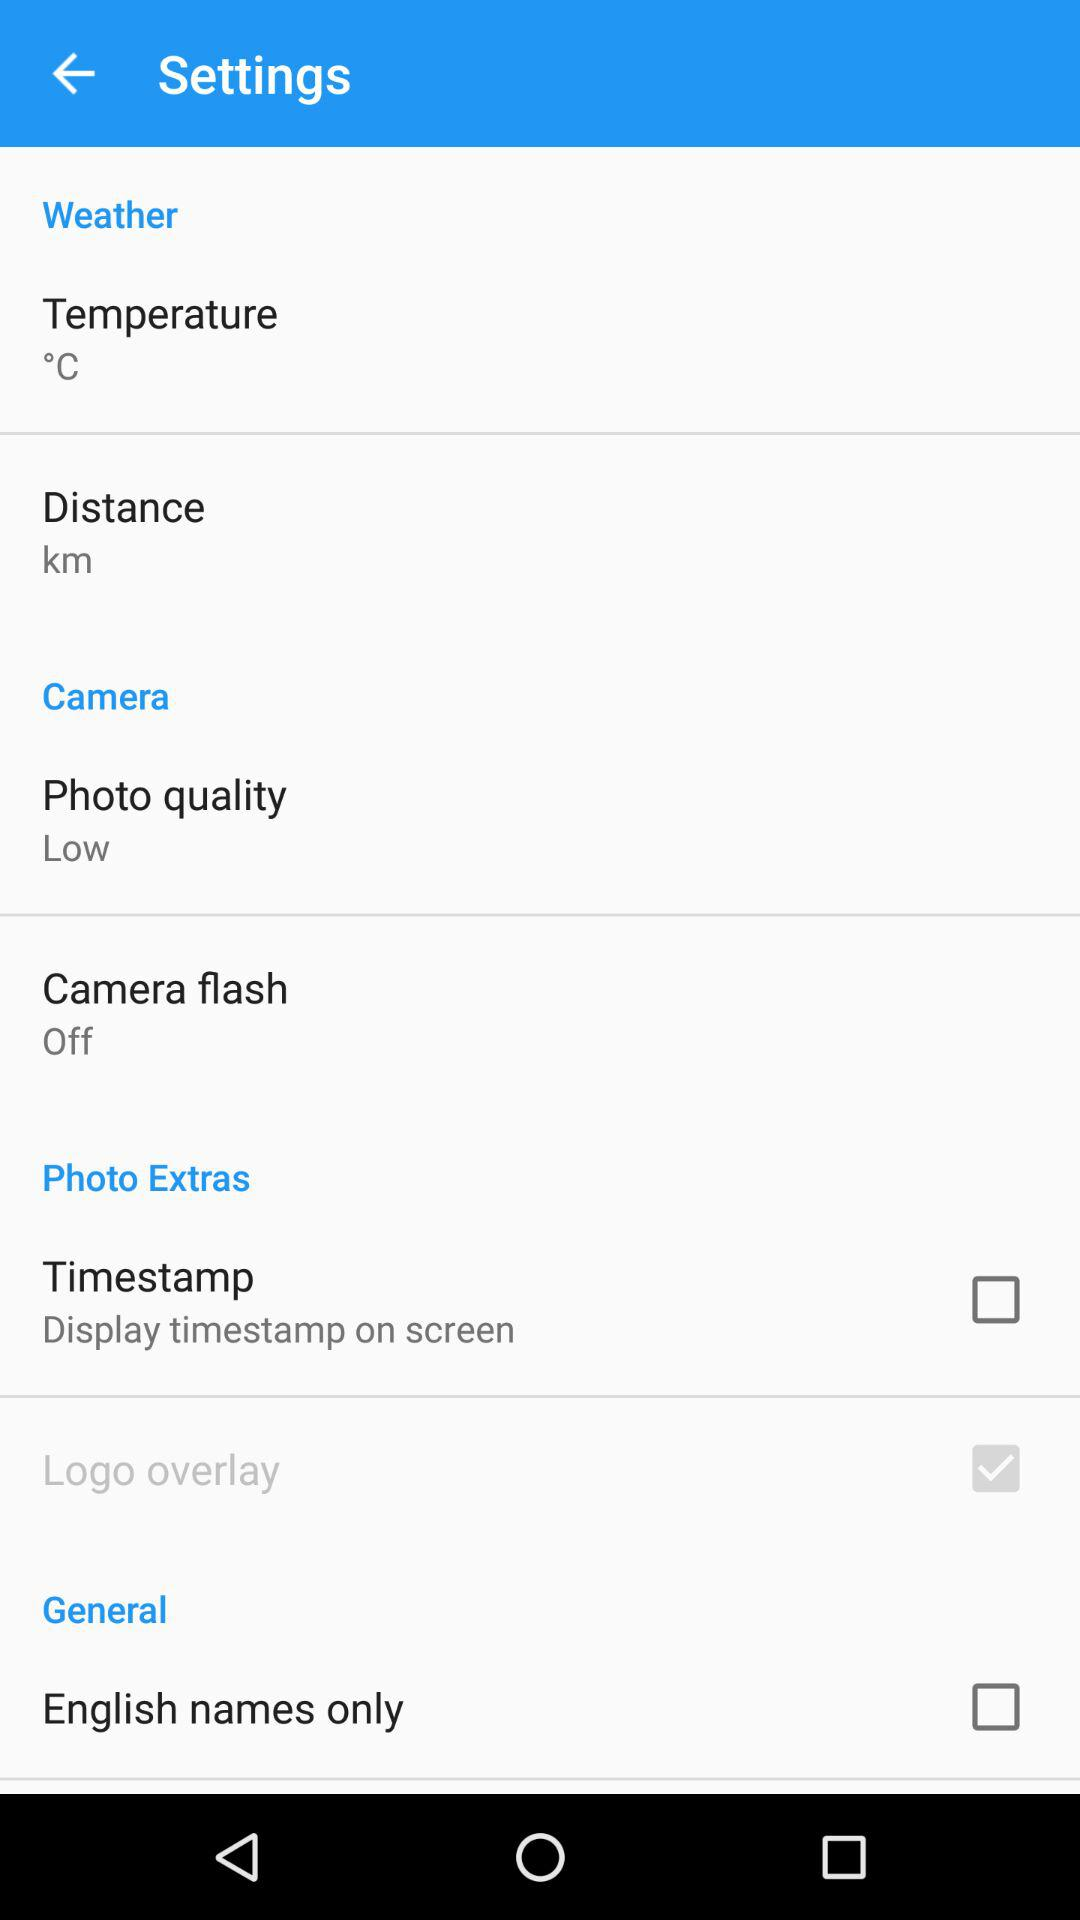What is the setting for "Camera flash"? The setting for "Camera flash" is "Off". 